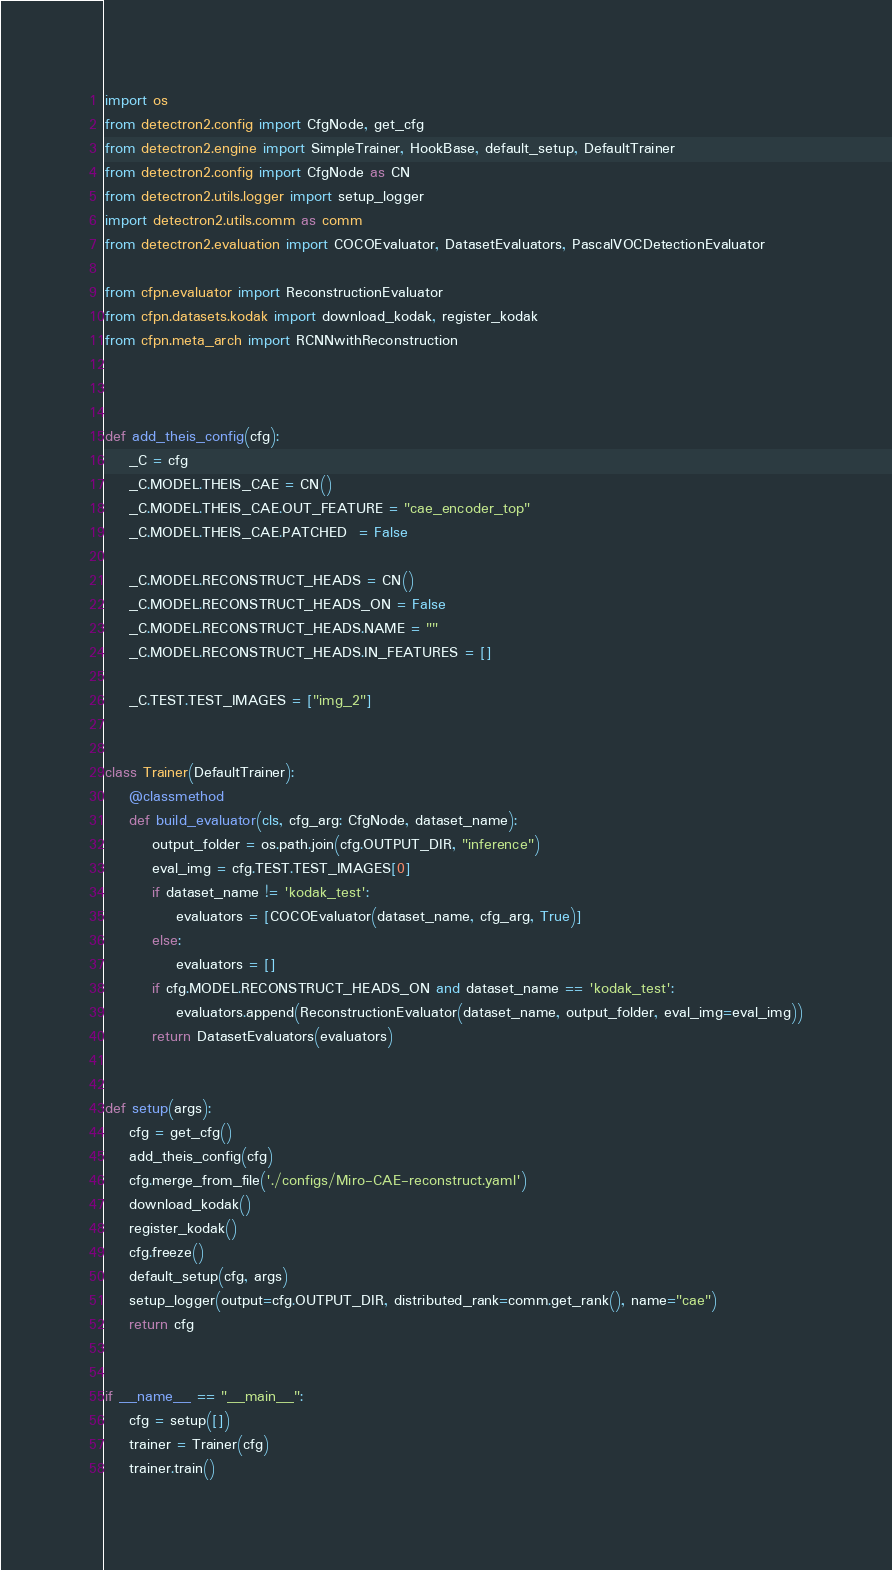Convert code to text. <code><loc_0><loc_0><loc_500><loc_500><_Python_>import os
from detectron2.config import CfgNode, get_cfg
from detectron2.engine import SimpleTrainer, HookBase, default_setup, DefaultTrainer
from detectron2.config import CfgNode as CN
from detectron2.utils.logger import setup_logger
import detectron2.utils.comm as comm
from detectron2.evaluation import COCOEvaluator, DatasetEvaluators, PascalVOCDetectionEvaluator

from cfpn.evaluator import ReconstructionEvaluator
from cfpn.datasets.kodak import download_kodak, register_kodak
from cfpn.meta_arch import RCNNwithReconstruction



def add_theis_config(cfg):
    _C = cfg
    _C.MODEL.THEIS_CAE = CN()
    _C.MODEL.THEIS_CAE.OUT_FEATURE = "cae_encoder_top"
    _C.MODEL.THEIS_CAE.PATCHED  = False

    _C.MODEL.RECONSTRUCT_HEADS = CN()
    _C.MODEL.RECONSTRUCT_HEADS_ON = False
    _C.MODEL.RECONSTRUCT_HEADS.NAME = ""
    _C.MODEL.RECONSTRUCT_HEADS.IN_FEATURES = []

    _C.TEST.TEST_IMAGES = ["img_2"]


class Trainer(DefaultTrainer):
    @classmethod
    def build_evaluator(cls, cfg_arg: CfgNode, dataset_name):
        output_folder = os.path.join(cfg.OUTPUT_DIR, "inference")
        eval_img = cfg.TEST.TEST_IMAGES[0]
        if dataset_name != 'kodak_test':
            evaluators = [COCOEvaluator(dataset_name, cfg_arg, True)]
        else:
            evaluators = []
        if cfg.MODEL.RECONSTRUCT_HEADS_ON and dataset_name == 'kodak_test':
            evaluators.append(ReconstructionEvaluator(dataset_name, output_folder, eval_img=eval_img))
        return DatasetEvaluators(evaluators)


def setup(args):
    cfg = get_cfg()
    add_theis_config(cfg)
    cfg.merge_from_file('./configs/Miro-CAE-reconstruct.yaml')
    download_kodak()
    register_kodak()
    cfg.freeze()
    default_setup(cfg, args)
    setup_logger(output=cfg.OUTPUT_DIR, distributed_rank=comm.get_rank(), name="cae")
    return cfg


if __name__ == "__main__":
    cfg = setup([])
    trainer = Trainer(cfg)
    trainer.train()
</code> 